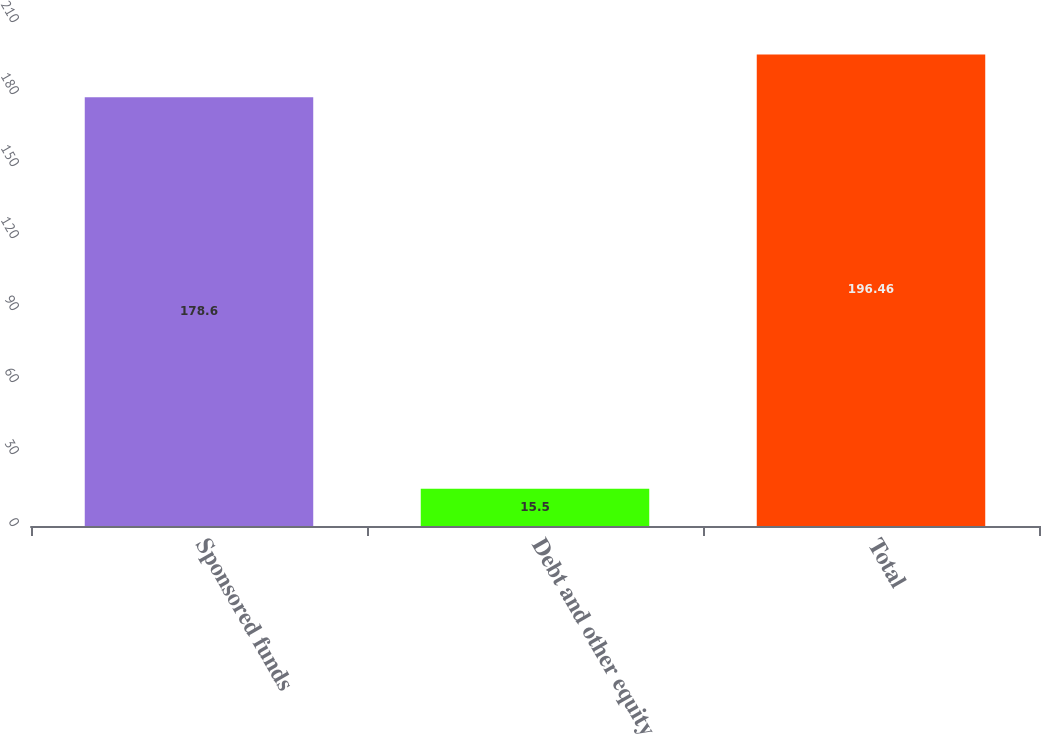Convert chart to OTSL. <chart><loc_0><loc_0><loc_500><loc_500><bar_chart><fcel>Sponsored funds<fcel>Debt and other equity<fcel>Total<nl><fcel>178.6<fcel>15.5<fcel>196.46<nl></chart> 